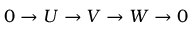<formula> <loc_0><loc_0><loc_500><loc_500>0 \to U \to V \to W \to 0</formula> 